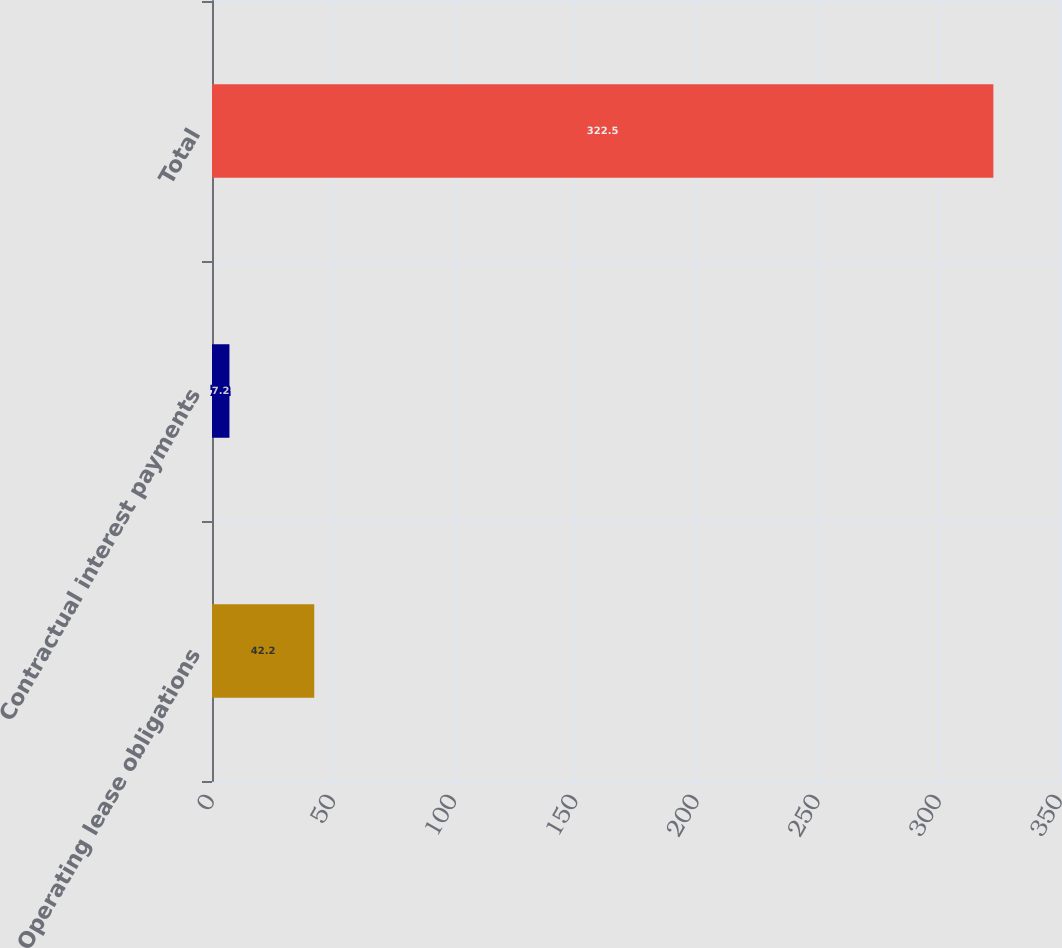<chart> <loc_0><loc_0><loc_500><loc_500><bar_chart><fcel>Operating lease obligations<fcel>Contractual interest payments<fcel>Total<nl><fcel>42.2<fcel>7.2<fcel>322.5<nl></chart> 